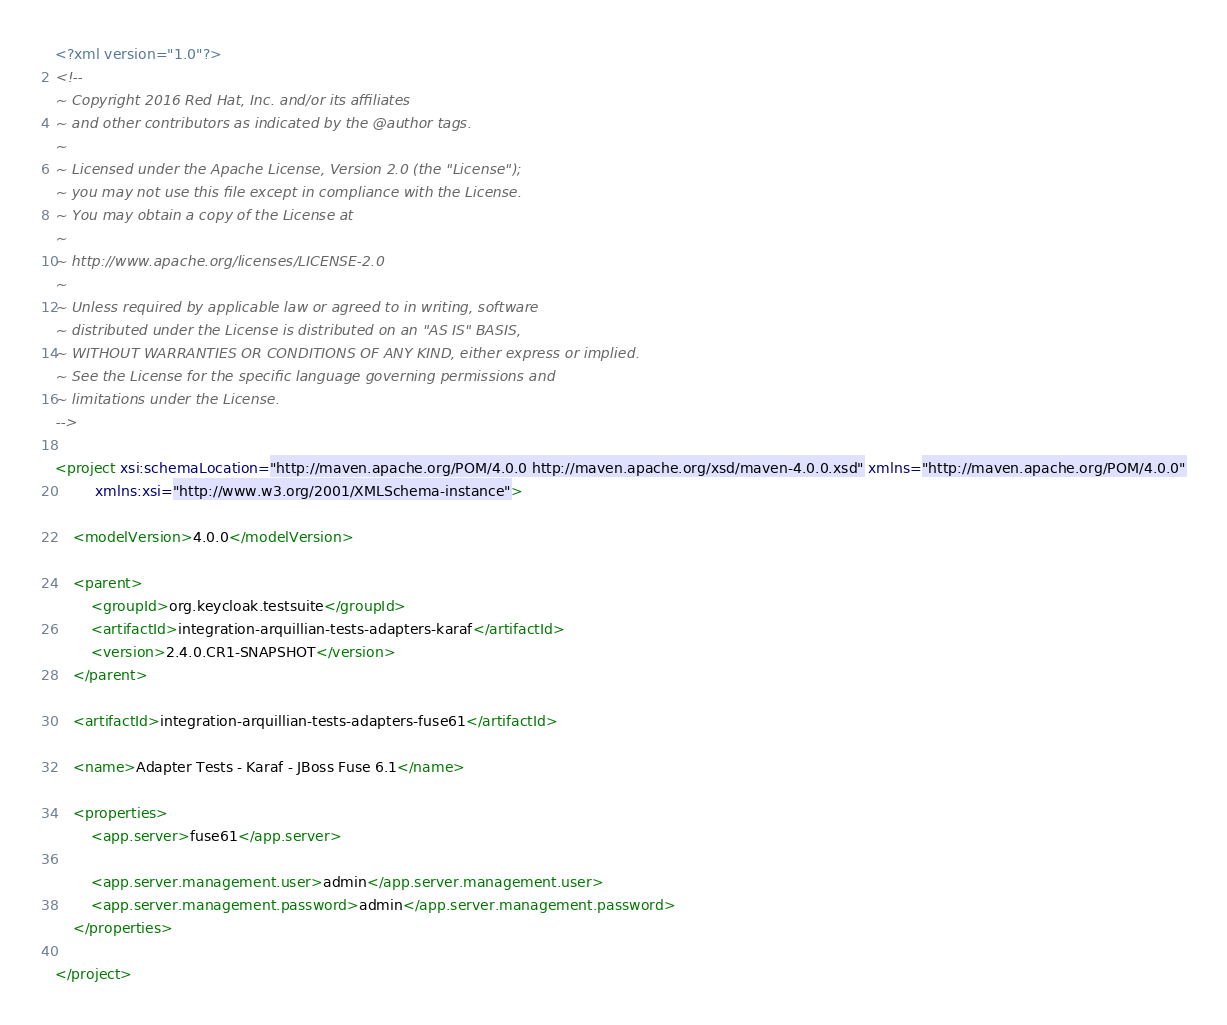Convert code to text. <code><loc_0><loc_0><loc_500><loc_500><_XML_><?xml version="1.0"?>
<!--
~ Copyright 2016 Red Hat, Inc. and/or its affiliates
~ and other contributors as indicated by the @author tags.
~
~ Licensed under the Apache License, Version 2.0 (the "License");
~ you may not use this file except in compliance with the License.
~ You may obtain a copy of the License at
~
~ http://www.apache.org/licenses/LICENSE-2.0
~
~ Unless required by applicable law or agreed to in writing, software
~ distributed under the License is distributed on an "AS IS" BASIS,
~ WITHOUT WARRANTIES OR CONDITIONS OF ANY KIND, either express or implied.
~ See the License for the specific language governing permissions and
~ limitations under the License.
-->

<project xsi:schemaLocation="http://maven.apache.org/POM/4.0.0 http://maven.apache.org/xsd/maven-4.0.0.xsd" xmlns="http://maven.apache.org/POM/4.0.0"
         xmlns:xsi="http://www.w3.org/2001/XMLSchema-instance">

    <modelVersion>4.0.0</modelVersion>

    <parent>
        <groupId>org.keycloak.testsuite</groupId>
        <artifactId>integration-arquillian-tests-adapters-karaf</artifactId>
        <version>2.4.0.CR1-SNAPSHOT</version>
    </parent>

    <artifactId>integration-arquillian-tests-adapters-fuse61</artifactId>

    <name>Adapter Tests - Karaf - JBoss Fuse 6.1</name>
        
    <properties>
        <app.server>fuse61</app.server>

        <app.server.management.user>admin</app.server.management.user>
        <app.server.management.password>admin</app.server.management.password>
    </properties>
    
</project></code> 